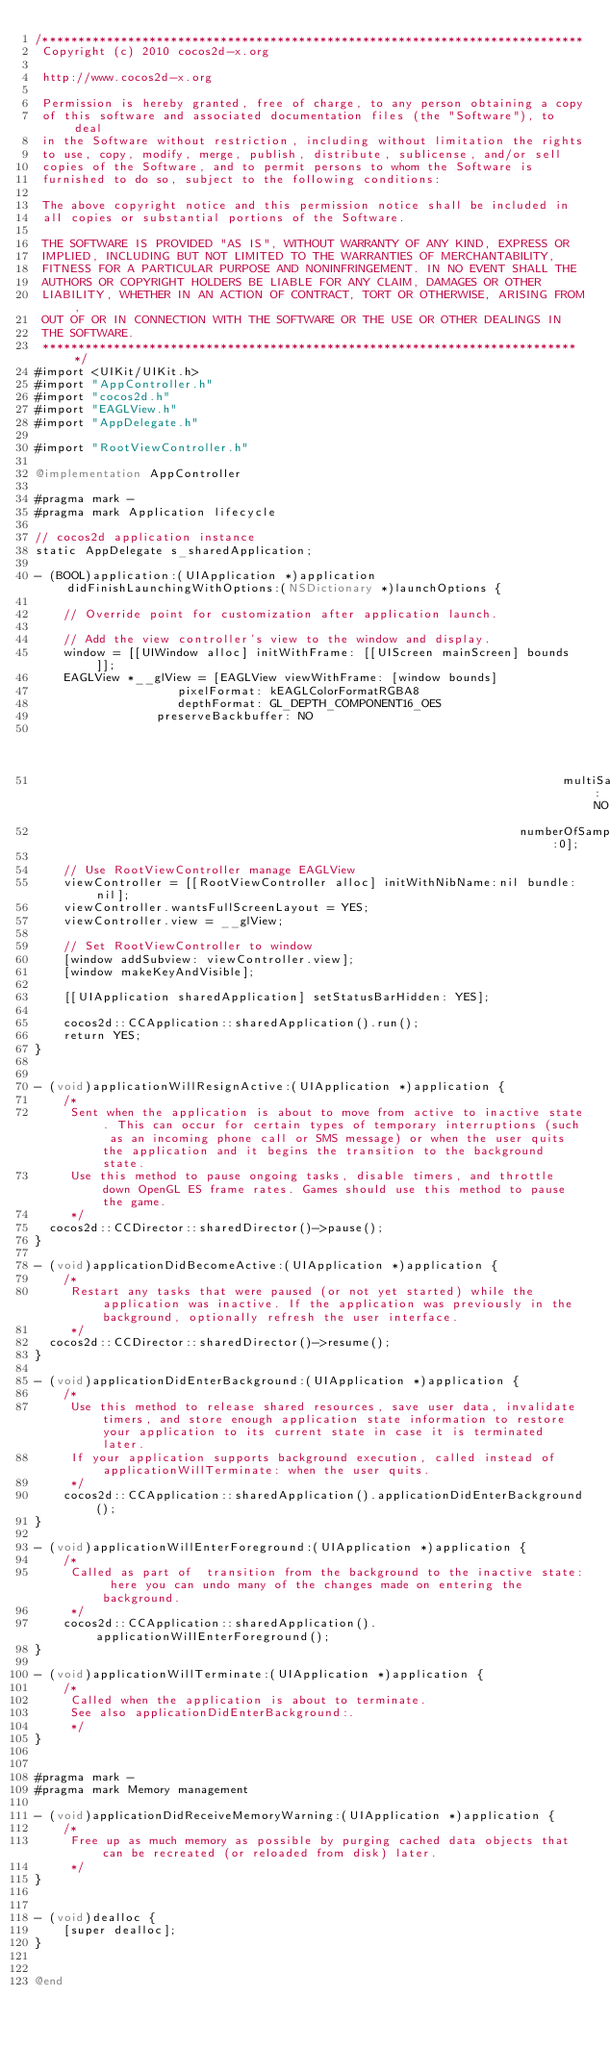<code> <loc_0><loc_0><loc_500><loc_500><_ObjectiveC_>/****************************************************************************
 Copyright (c) 2010 cocos2d-x.org
 
 http://www.cocos2d-x.org
 
 Permission is hereby granted, free of charge, to any person obtaining a copy
 of this software and associated documentation files (the "Software"), to deal
 in the Software without restriction, including without limitation the rights
 to use, copy, modify, merge, publish, distribute, sublicense, and/or sell
 copies of the Software, and to permit persons to whom the Software is
 furnished to do so, subject to the following conditions:
 
 The above copyright notice and this permission notice shall be included in
 all copies or substantial portions of the Software.
 
 THE SOFTWARE IS PROVIDED "AS IS", WITHOUT WARRANTY OF ANY KIND, EXPRESS OR
 IMPLIED, INCLUDING BUT NOT LIMITED TO THE WARRANTIES OF MERCHANTABILITY,
 FITNESS FOR A PARTICULAR PURPOSE AND NONINFRINGEMENT. IN NO EVENT SHALL THE
 AUTHORS OR COPYRIGHT HOLDERS BE LIABLE FOR ANY CLAIM, DAMAGES OR OTHER
 LIABILITY, WHETHER IN AN ACTION OF CONTRACT, TORT OR OTHERWISE, ARISING FROM,
 OUT OF OR IN CONNECTION WITH THE SOFTWARE OR THE USE OR OTHER DEALINGS IN
 THE SOFTWARE.
 ****************************************************************************/
#import <UIKit/UIKit.h>
#import "AppController.h"
#import "cocos2d.h"
#import "EAGLView.h"
#import "AppDelegate.h"

#import "RootViewController.h"

@implementation AppController

#pragma mark -
#pragma mark Application lifecycle

// cocos2d application instance
static AppDelegate s_sharedApplication;

- (BOOL)application:(UIApplication *)application didFinishLaunchingWithOptions:(NSDictionary *)launchOptions {    
    
    // Override point for customization after application launch.

    // Add the view controller's view to the window and display.
    window = [[UIWindow alloc] initWithFrame: [[UIScreen mainScreen] bounds]];
    EAGLView *__glView = [EAGLView viewWithFrame: [window bounds]
										pixelFormat: kEAGLColorFormatRGBA8
										depthFormat: GL_DEPTH_COMPONENT16_OES
								 preserveBackbuffer: NO
                                                                                 sharegroup:nil
                                                                          multiSampling:NO
                                                                    numberOfSamples:0];
    
    // Use RootViewController manage EAGLView 
    viewController = [[RootViewController alloc] initWithNibName:nil bundle:nil];
    viewController.wantsFullScreenLayout = YES;
    viewController.view = __glView;

    // Set RootViewController to window
    [window addSubview: viewController.view];
    [window makeKeyAndVisible];

    [[UIApplication sharedApplication] setStatusBarHidden: YES];
    
    cocos2d::CCApplication::sharedApplication().run();
    return YES;
}


- (void)applicationWillResignActive:(UIApplication *)application {
    /*
     Sent when the application is about to move from active to inactive state. This can occur for certain types of temporary interruptions (such as an incoming phone call or SMS message) or when the user quits the application and it begins the transition to the background state.
     Use this method to pause ongoing tasks, disable timers, and throttle down OpenGL ES frame rates. Games should use this method to pause the game.
     */
	cocos2d::CCDirector::sharedDirector()->pause();
}

- (void)applicationDidBecomeActive:(UIApplication *)application {
    /*
     Restart any tasks that were paused (or not yet started) while the application was inactive. If the application was previously in the background, optionally refresh the user interface.
     */
	cocos2d::CCDirector::sharedDirector()->resume();
}

- (void)applicationDidEnterBackground:(UIApplication *)application {
    /*
     Use this method to release shared resources, save user data, invalidate timers, and store enough application state information to restore your application to its current state in case it is terminated later. 
     If your application supports background execution, called instead of applicationWillTerminate: when the user quits.
     */
    cocos2d::CCApplication::sharedApplication().applicationDidEnterBackground();
}

- (void)applicationWillEnterForeground:(UIApplication *)application {
    /*
     Called as part of  transition from the background to the inactive state: here you can undo many of the changes made on entering the background.
     */
    cocos2d::CCApplication::sharedApplication().applicationWillEnterForeground();
}

- (void)applicationWillTerminate:(UIApplication *)application {
    /*
     Called when the application is about to terminate.
     See also applicationDidEnterBackground:.
     */
}


#pragma mark -
#pragma mark Memory management

- (void)applicationDidReceiveMemoryWarning:(UIApplication *)application {
    /*
     Free up as much memory as possible by purging cached data objects that can be recreated (or reloaded from disk) later.
     */
}


- (void)dealloc {
    [super dealloc];
}


@end

</code> 